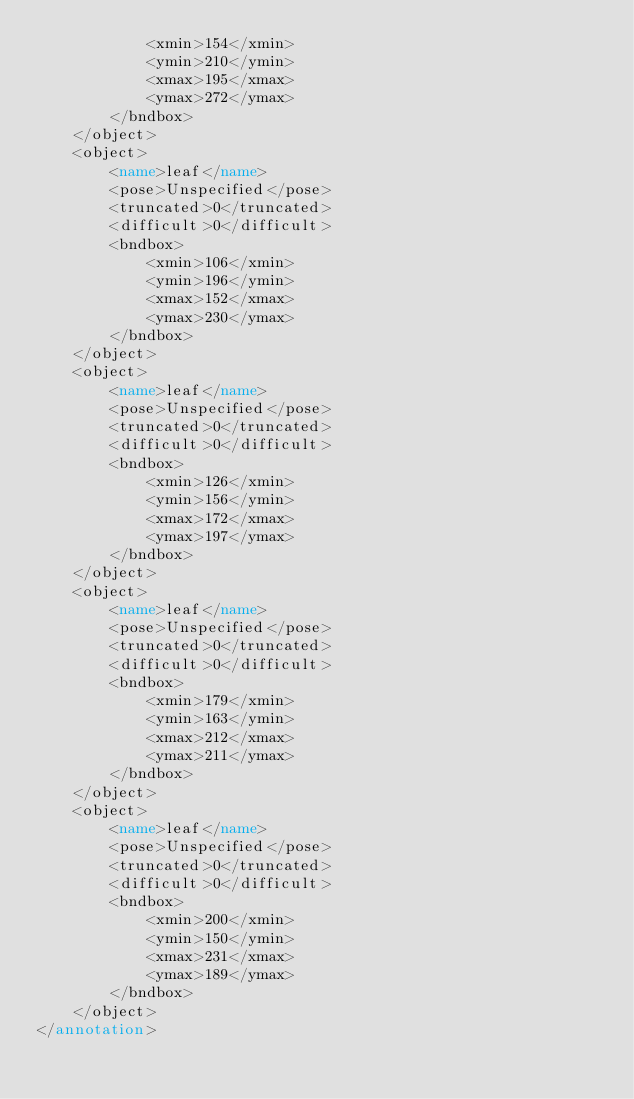<code> <loc_0><loc_0><loc_500><loc_500><_XML_>            <xmin>154</xmin>
            <ymin>210</ymin>
            <xmax>195</xmax>
            <ymax>272</ymax>
        </bndbox>
    </object>
    <object>
        <name>leaf</name>
        <pose>Unspecified</pose>
        <truncated>0</truncated>
        <difficult>0</difficult>
        <bndbox>
            <xmin>106</xmin>
            <ymin>196</ymin>
            <xmax>152</xmax>
            <ymax>230</ymax>
        </bndbox>
    </object>
    <object>
        <name>leaf</name>
        <pose>Unspecified</pose>
        <truncated>0</truncated>
        <difficult>0</difficult>
        <bndbox>
            <xmin>126</xmin>
            <ymin>156</ymin>
            <xmax>172</xmax>
            <ymax>197</ymax>
        </bndbox>
    </object>
    <object>
        <name>leaf</name>
        <pose>Unspecified</pose>
        <truncated>0</truncated>
        <difficult>0</difficult>
        <bndbox>
            <xmin>179</xmin>
            <ymin>163</ymin>
            <xmax>212</xmax>
            <ymax>211</ymax>
        </bndbox>
    </object>
    <object>
        <name>leaf</name>
        <pose>Unspecified</pose>
        <truncated>0</truncated>
        <difficult>0</difficult>
        <bndbox>
            <xmin>200</xmin>
            <ymin>150</ymin>
            <xmax>231</xmax>
            <ymax>189</ymax>
        </bndbox>
    </object>
</annotation>
</code> 